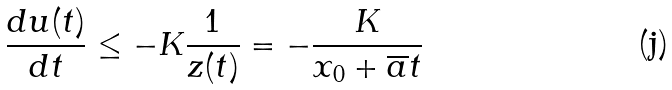Convert formula to latex. <formula><loc_0><loc_0><loc_500><loc_500>\frac { d u ( t ) } { d t } \leq - K \frac { 1 } { z ( t ) } = - \frac { K } { x _ { 0 } + \overline { a } t }</formula> 